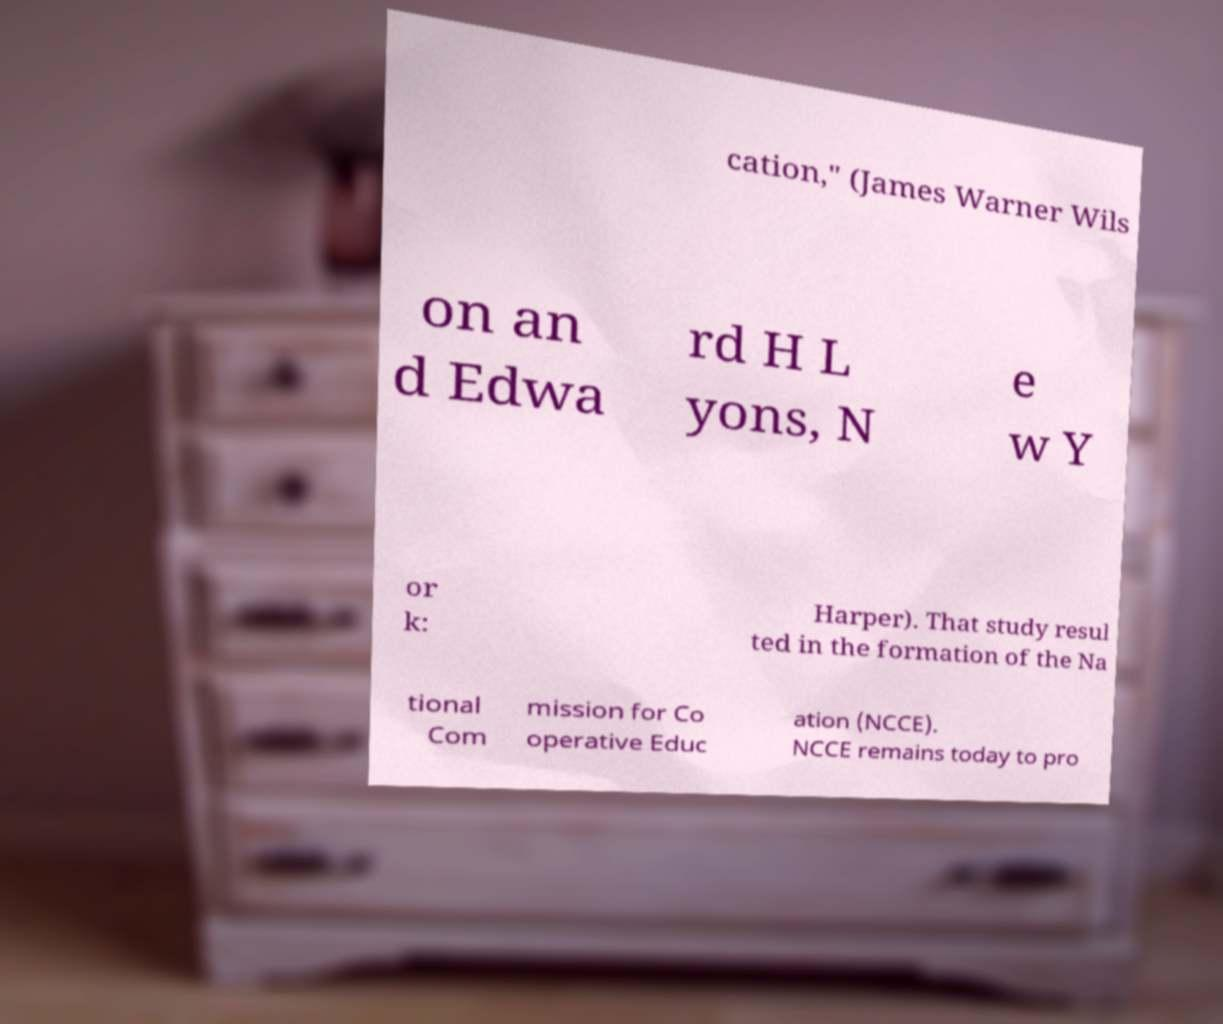I need the written content from this picture converted into text. Can you do that? cation," (James Warner Wils on an d Edwa rd H L yons, N e w Y or k: Harper). That study resul ted in the formation of the Na tional Com mission for Co operative Educ ation (NCCE). NCCE remains today to pro 